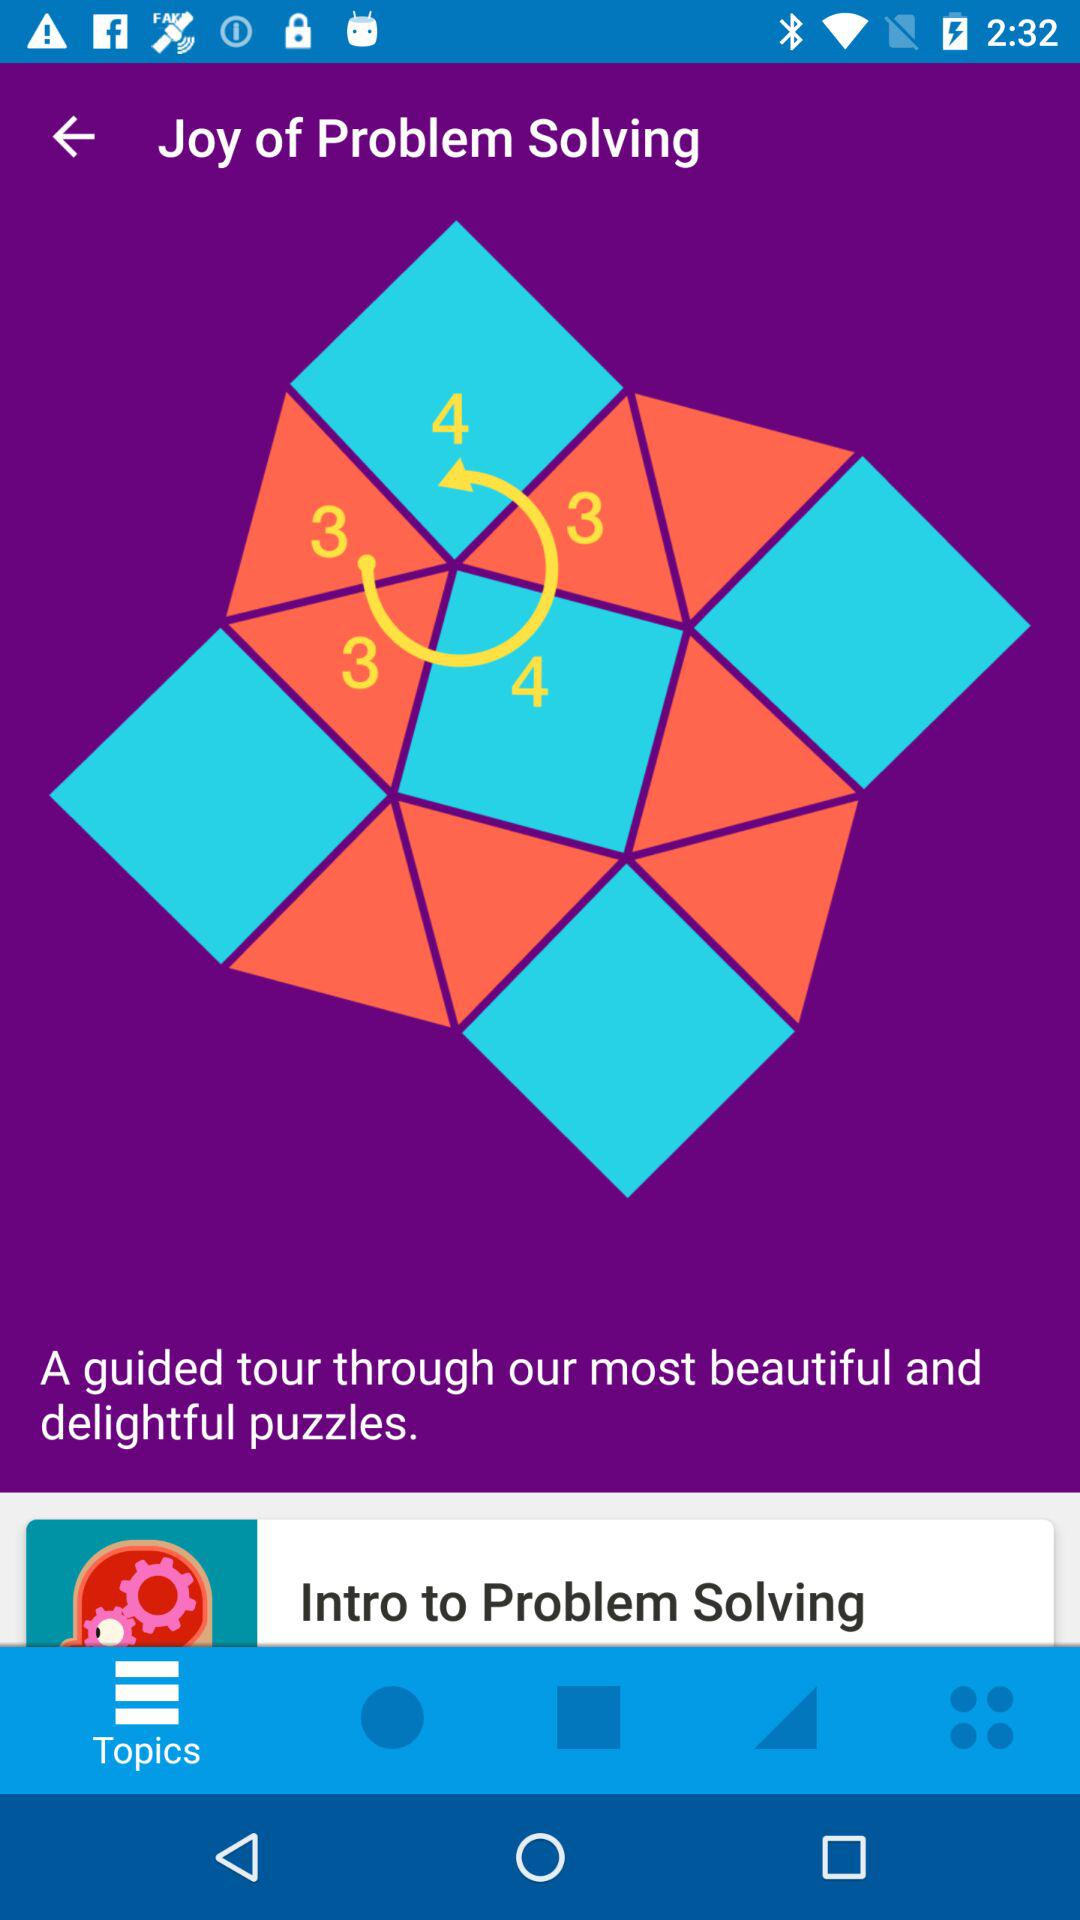Which tab is currently selected? The currently selected tab is "Topics". 